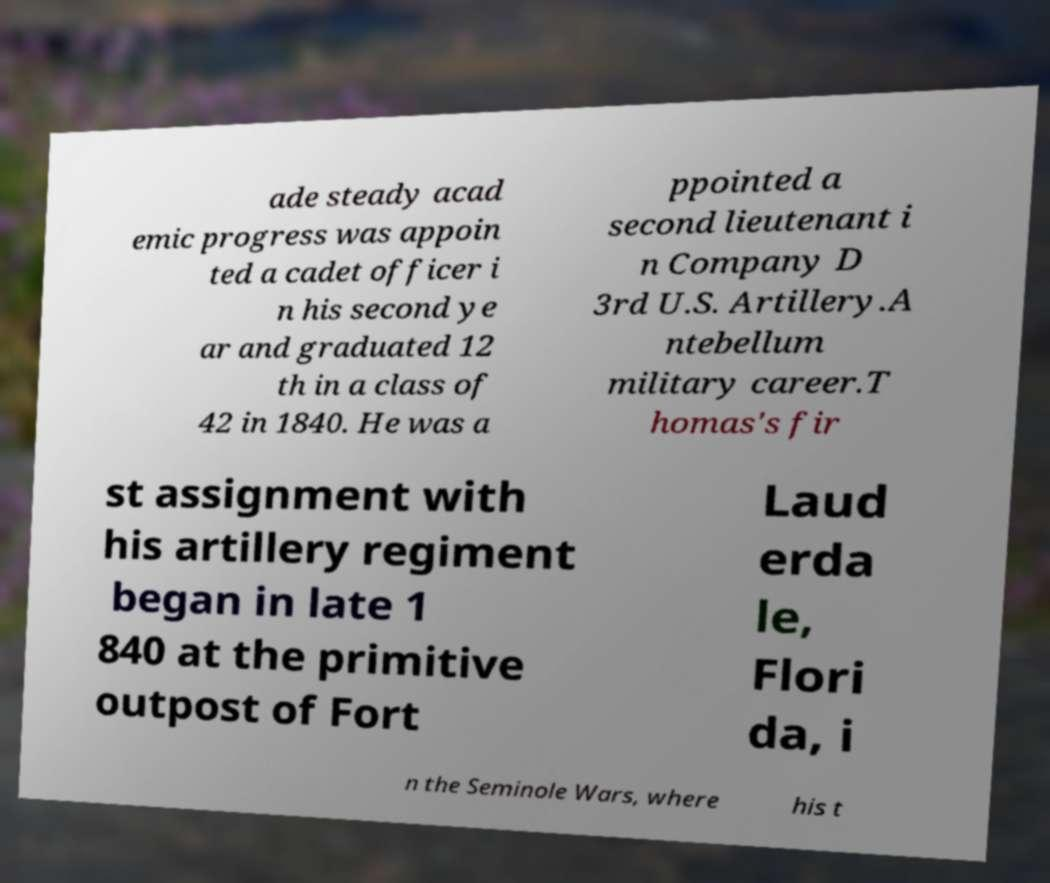There's text embedded in this image that I need extracted. Can you transcribe it verbatim? ade steady acad emic progress was appoin ted a cadet officer i n his second ye ar and graduated 12 th in a class of 42 in 1840. He was a ppointed a second lieutenant i n Company D 3rd U.S. Artillery.A ntebellum military career.T homas's fir st assignment with his artillery regiment began in late 1 840 at the primitive outpost of Fort Laud erda le, Flori da, i n the Seminole Wars, where his t 